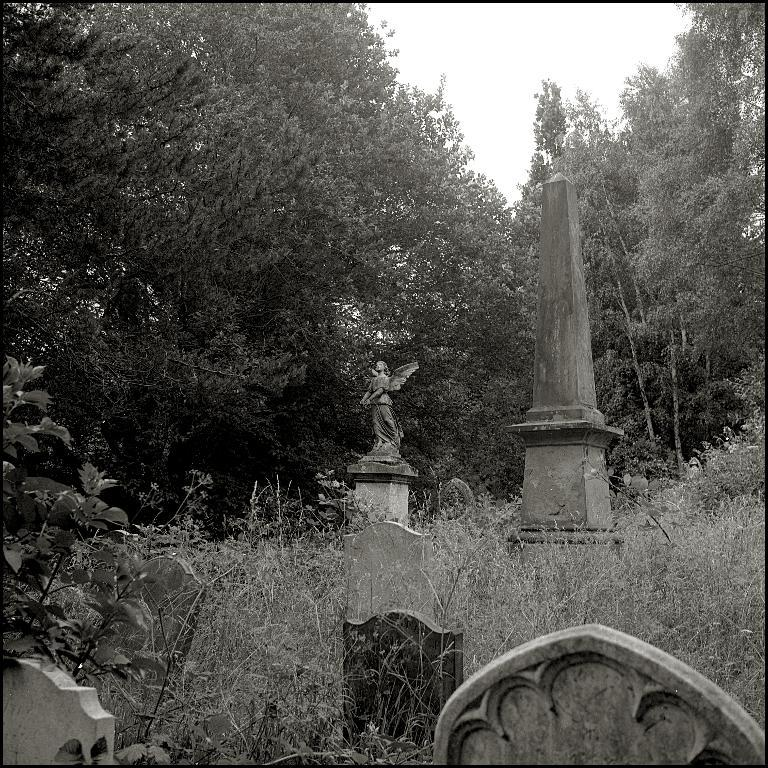What is the color scheme of the image? The image is black and white and white. What is the main subject in the image? There is a statue in the image. What type of natural elements can be seen in the image? There are trees in the image. What type of man-made structure is present in the image? There is a concrete structure in the image. What is visible at the top of the image? The sky is visible at the top of the image. What type of copper material is used to create the statue in the image? There is no mention of copper or any specific material used to create the statue in the image. The statue is simply described as being present in the image. 